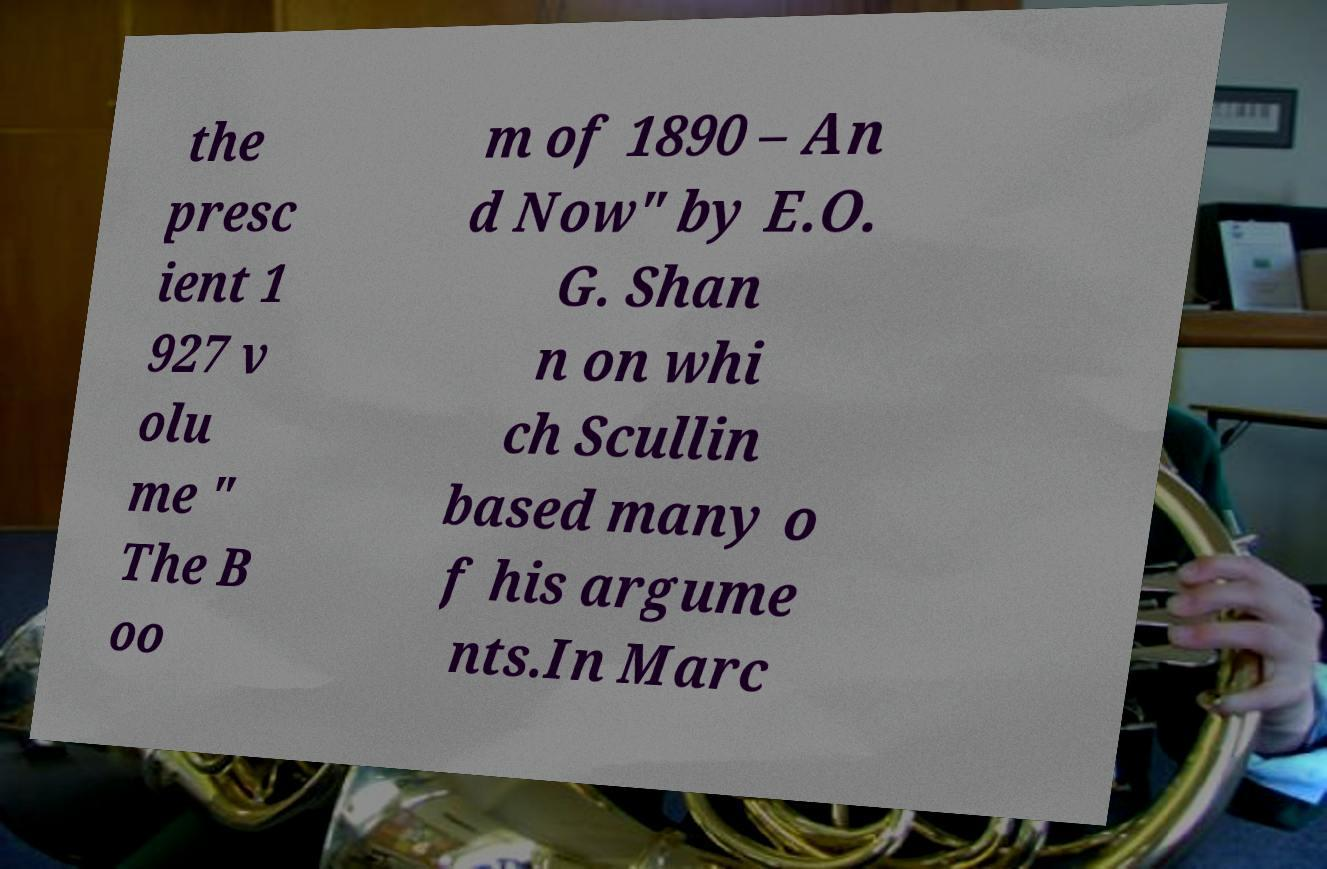Could you extract and type out the text from this image? the presc ient 1 927 v olu me " The B oo m of 1890 – An d Now" by E.O. G. Shan n on whi ch Scullin based many o f his argume nts.In Marc 